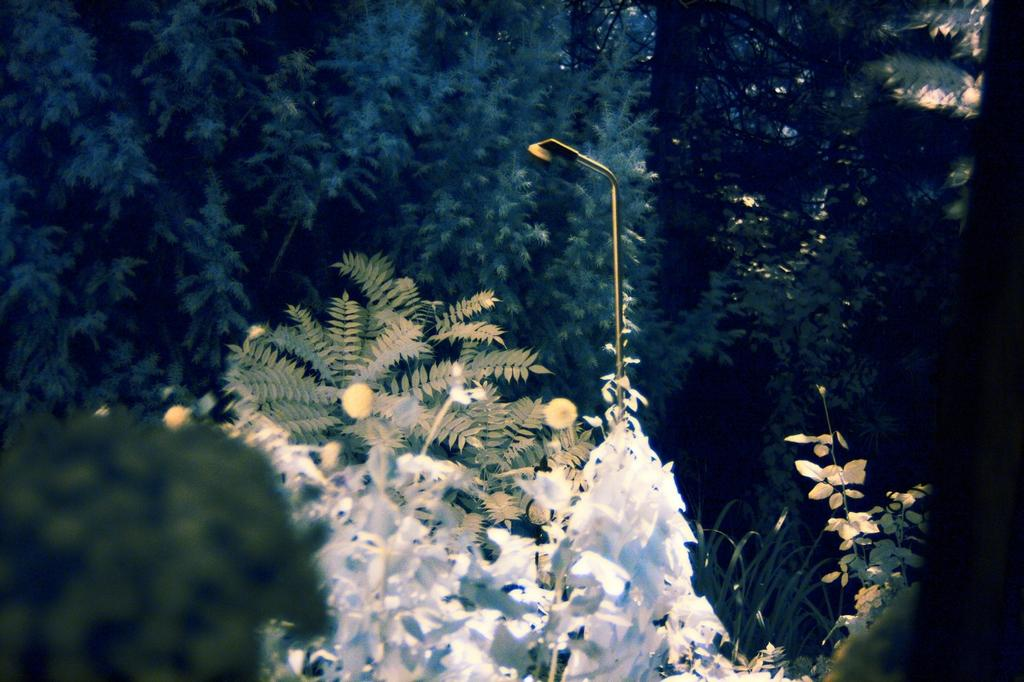What is the main object in the middle of the image? There is a street light in the middle of the image. What else can be seen in the image besides the street light? There are plants and trees in the image. What type of hat is the tree wearing in the image? There are no hats present in the image, as trees do not wear hats. What achievements has the plant accomplished in the image? The image does not provide information about the plants' achievements, as plants do not have achievements. 